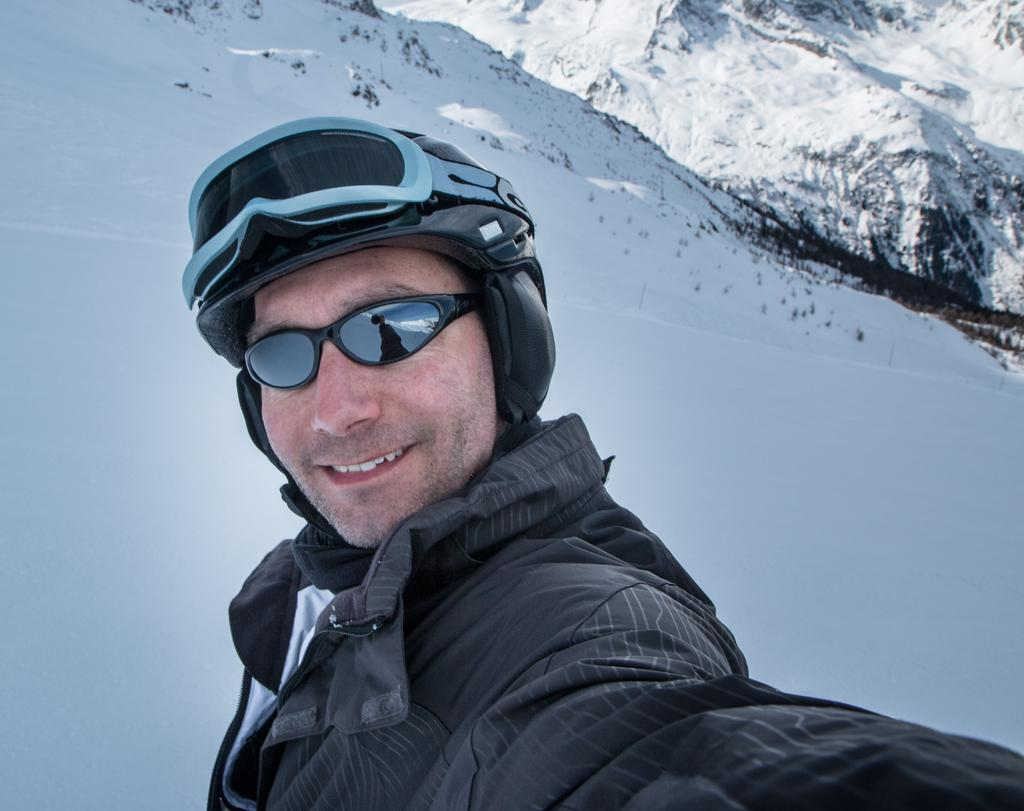Who is present in the image? There is a man in the image. What is the man wearing on his face? The man is wearing glasses. What type of protective gear is the man wearing? The man is wearing a helmet. What type of natural formations can be seen in the image? There are ice hills visible in the image. What type of zephyr can be seen blowing through the calendar in the image? There is no zephyr or calendar present in the image. 